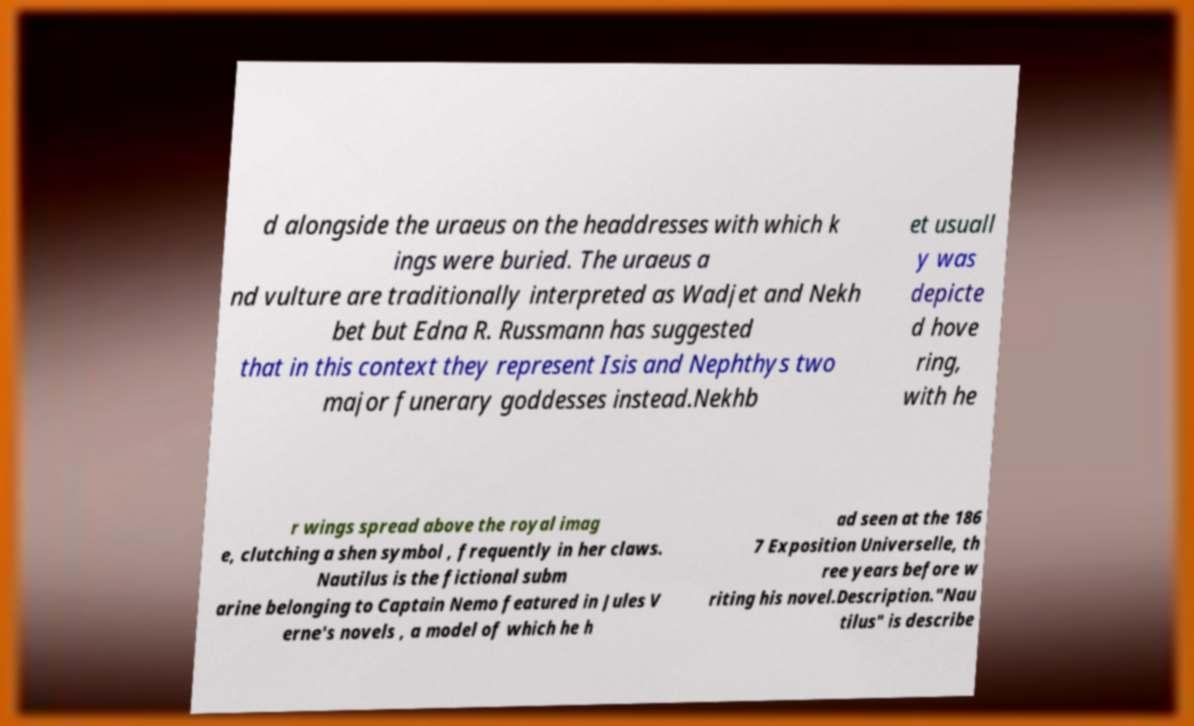Can you read and provide the text displayed in the image?This photo seems to have some interesting text. Can you extract and type it out for me? d alongside the uraeus on the headdresses with which k ings were buried. The uraeus a nd vulture are traditionally interpreted as Wadjet and Nekh bet but Edna R. Russmann has suggested that in this context they represent Isis and Nephthys two major funerary goddesses instead.Nekhb et usuall y was depicte d hove ring, with he r wings spread above the royal imag e, clutching a shen symbol , frequently in her claws. Nautilus is the fictional subm arine belonging to Captain Nemo featured in Jules V erne's novels , a model of which he h ad seen at the 186 7 Exposition Universelle, th ree years before w riting his novel.Description."Nau tilus" is describe 